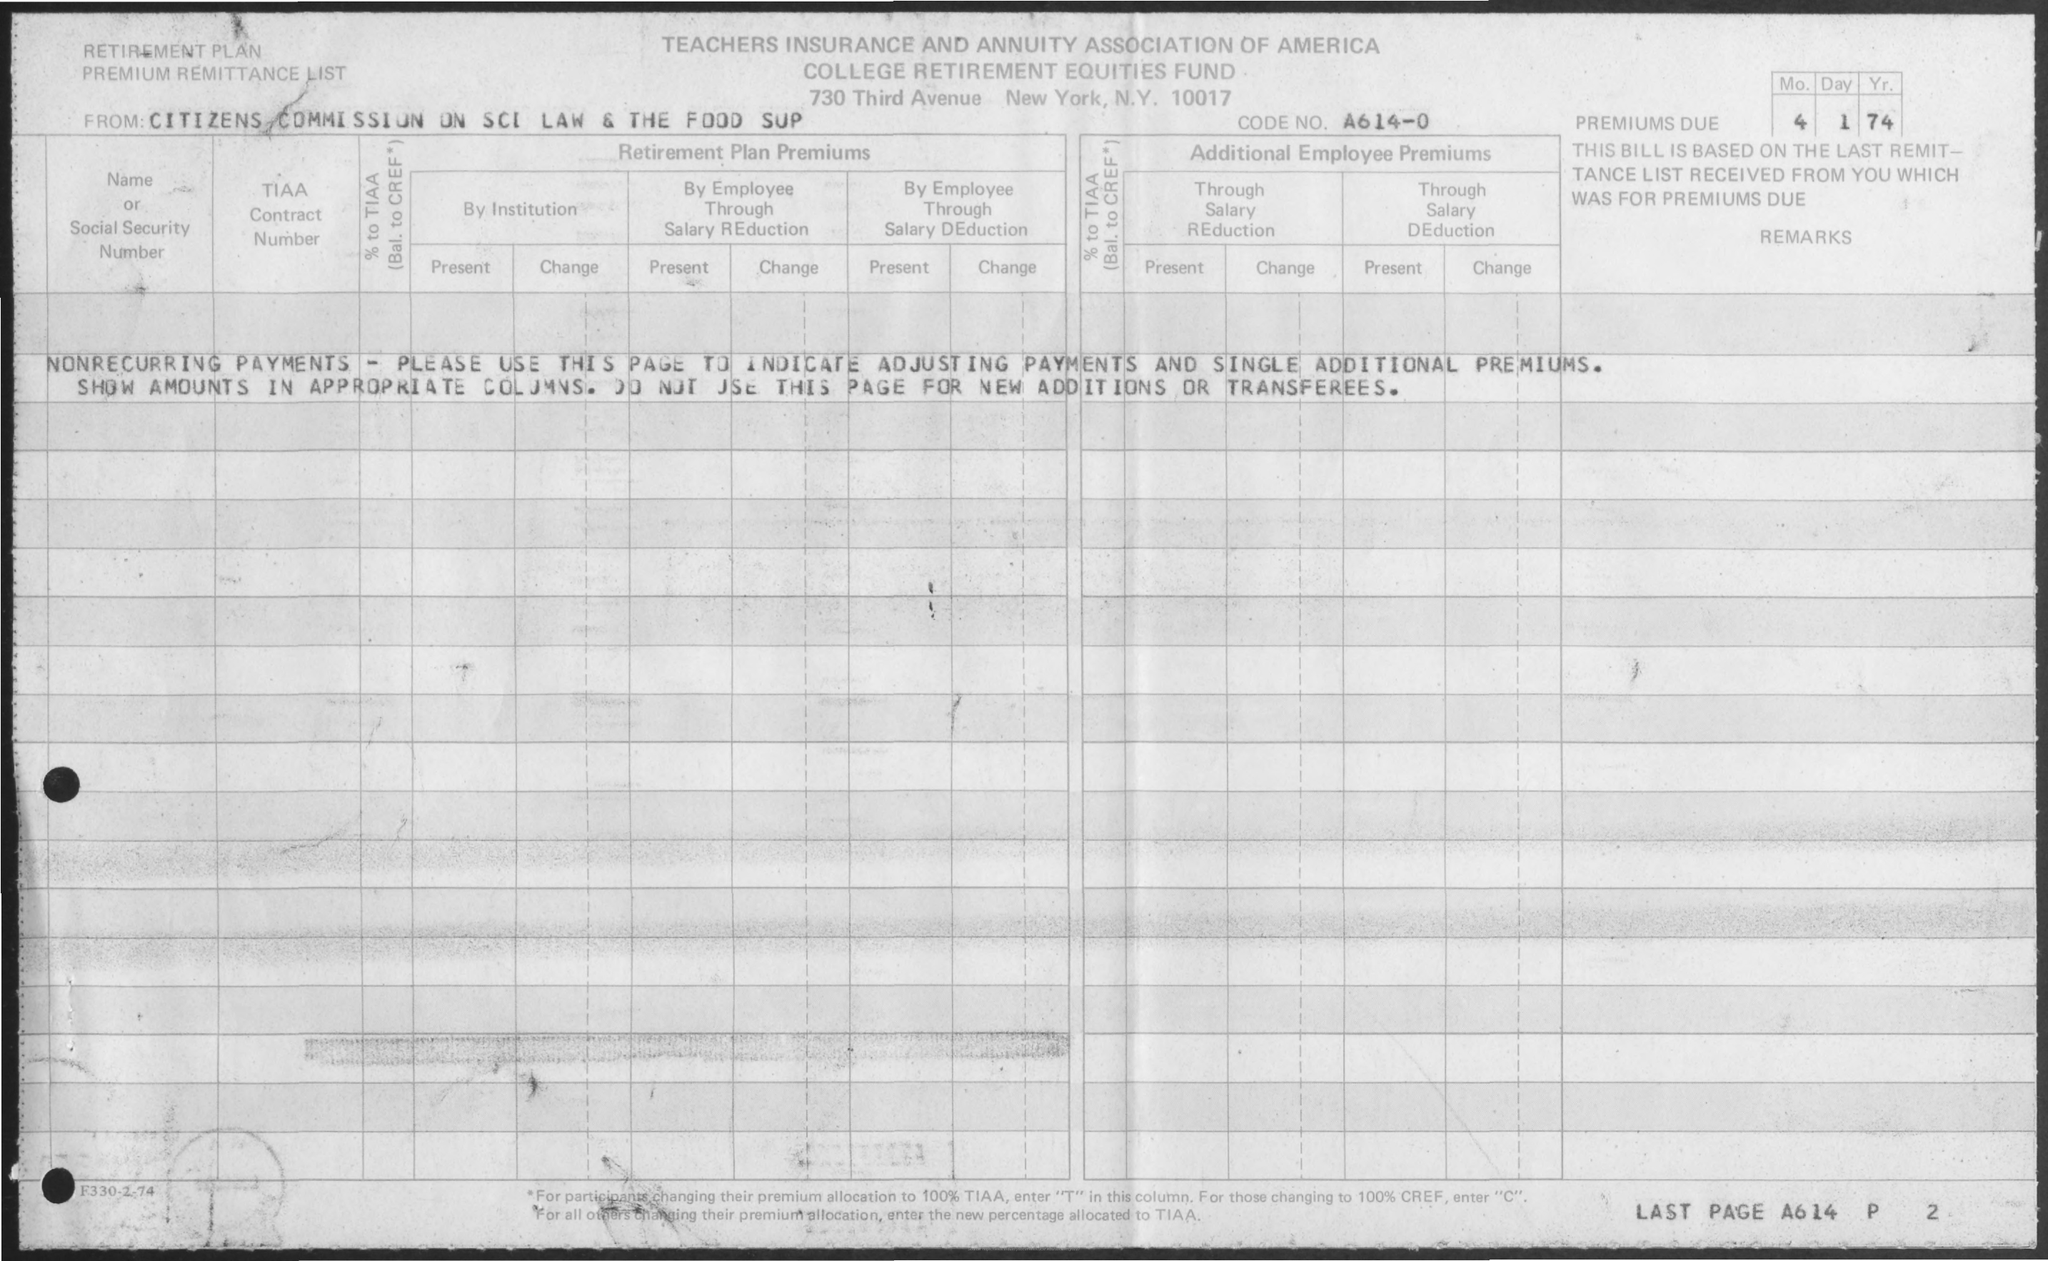Could you describe the entity listed on the document? The entity listed is the 'Citizens Commission on Sci Law & the Food Sup,' which seems to be an abbreviated representation of a commission related to science, law, or food supply. This commission may have been responsible for contributing to the retirement plans managed by the association. What might this commission have been concerned with? While the specific responsibilities are not detailed in this document, a 'Citizens Commission on Sci Law & the Food Sup' might potentially be involved with issues at the intersection of science, law, and food supply—possibly looking at policy formation, research on food security, or regulation of scientific methods in food production. 